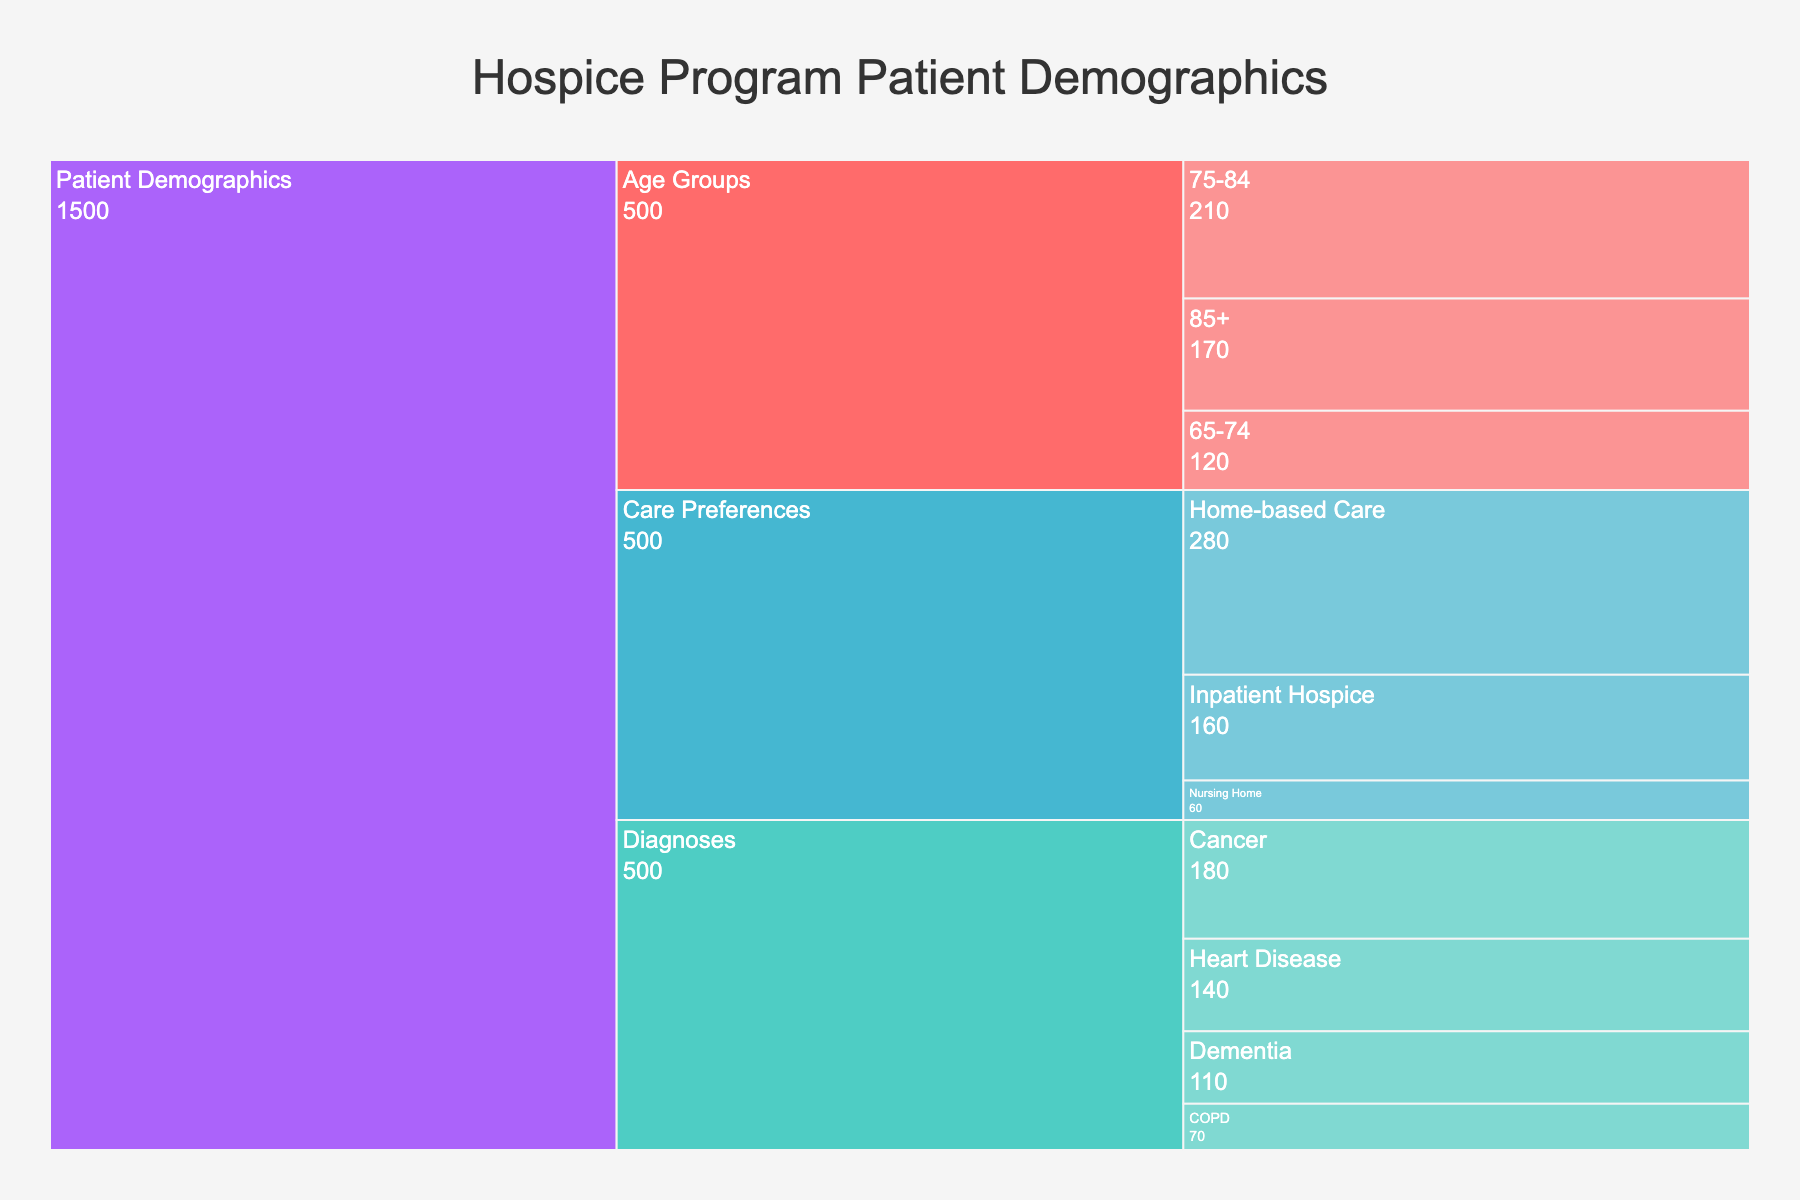What's the total number of patients aged 75 and older? Sum the values for the age groups 75-84 (210) and 85+ (170), which gives 210 + 170 = 380
Answer: 380 What percent of the total patients prefer home-based care? Sum the values for all care preferences: Home-based Care (280), Inpatient Hospice (160), and Nursing Home (60), which gives 280 + 160 + 60 = 500. Then, calculate the percentage for Home-based Care: (280 / 500) * 100 = 56%
Answer: 56% Which diagnosis category has the fewest patients? Compare the values for each diagnosis: Cancer (180), Heart Disease (140), Dementia (110), COPD (70). COPD has the smallest number of patients
Answer: COPD Are there more patients aged 65-74 or more patients with Cancer? Compare the number of patients aged 65-74 (120) with the number of Cancer patients (180). Since 180 > 120, there are more Cancer patients
Answer: More Cancer patients What's the difference in patient count between those aged 65-74 and those preferring nursing home care? Subtract the number of patients preferring nursing home care (60) from those aged 65-74 (120): 120 - 60 = 60
Answer: 60 Which care preference is the least common among patients? Compare the values for each care preference: Home-based Care (280), Inpatient Hospice (160), and Nursing Home (60). Nursing Home has the fewest
Answer: Nursing Home How many patients are there in total with heart disease or dementia? Add the values for Heart Disease (140) and Dementia (110): 140 + 110 = 250
Answer: 250 What is the proportion of patients diagnosed with COPD compared to those diagnosed with Cancer? Divide the number of COPD patients (70) by the number of Cancer patients (180): 70 / 180 ≈ 0.39. So, the proportion is approximately 0.39
Answer: 0.39 Is the number of patients in the 75-84 age group closer to the number of those with heart disease or those preferring inpatient hospice care? Check the values for the 75-84 age group (210), heart disease (140), and inpatient hospice care (160). The number 210 is closer to 160 than it is to 140
Answer: Closer to inpatient hospice care What is the median value for the number of patients across all diagnoses? The values are Cancer (180), Heart Disease (140), Dementia (110), and COPD (70). Arrange them in ascending order: 70, 110, 140, 180. The median value is the average of the two middle numbers: (110 + 140) / 2 = 125
Answer: 125 